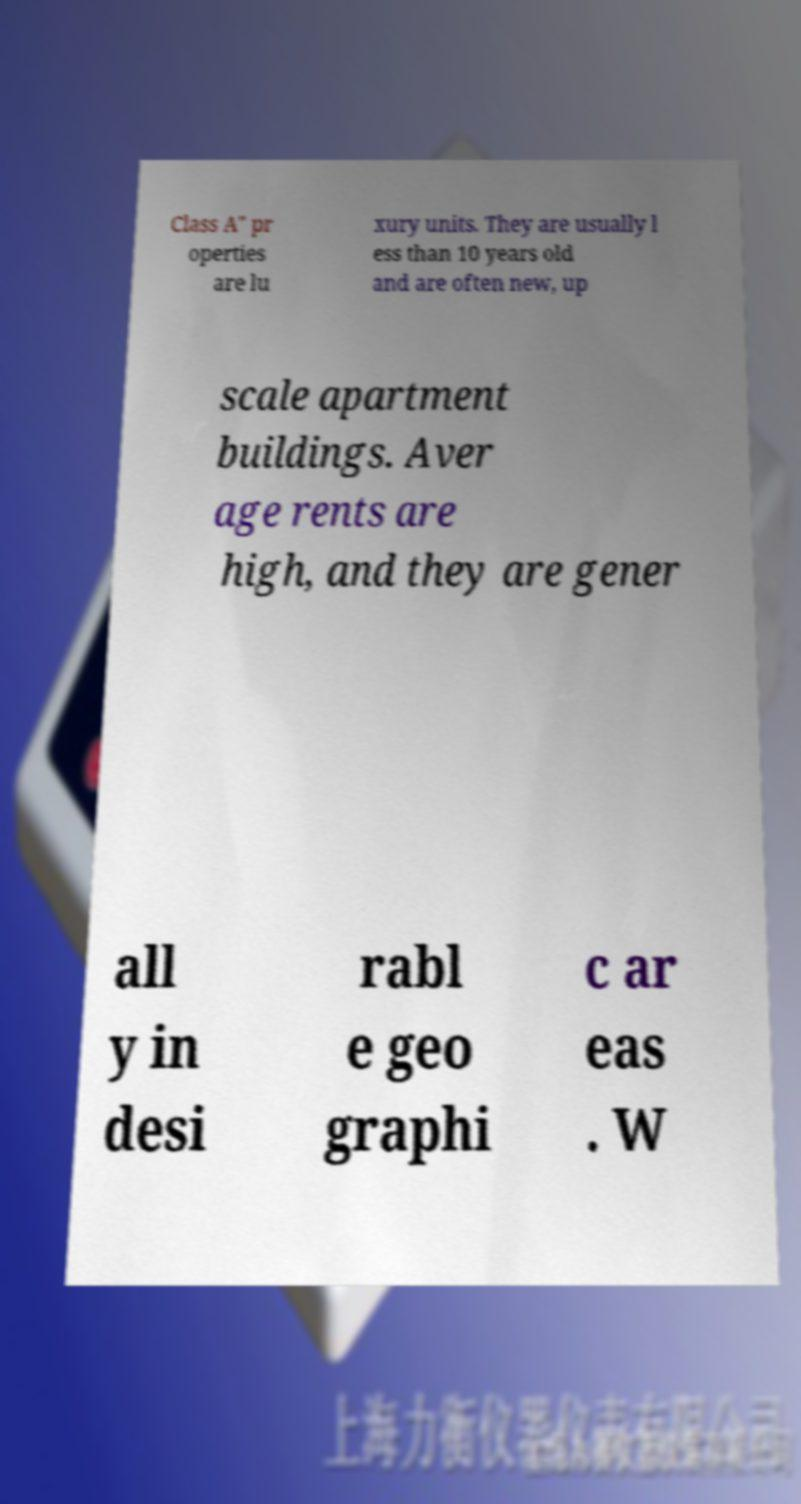Please read and relay the text visible in this image. What does it say? Class A" pr operties are lu xury units. They are usually l ess than 10 years old and are often new, up scale apartment buildings. Aver age rents are high, and they are gener all y in desi rabl e geo graphi c ar eas . W 